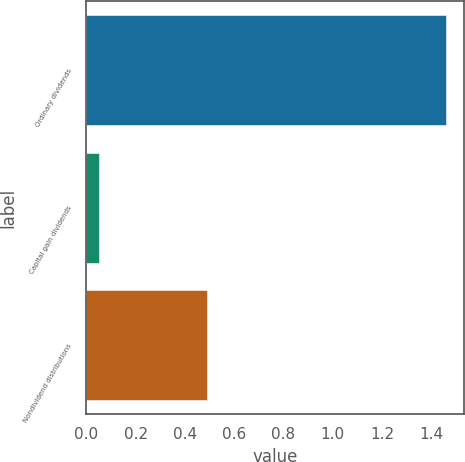<chart> <loc_0><loc_0><loc_500><loc_500><bar_chart><fcel>Ordinary dividends<fcel>Capital gain dividends<fcel>Nondividend distributions<nl><fcel>1.46<fcel>0.05<fcel>0.49<nl></chart> 